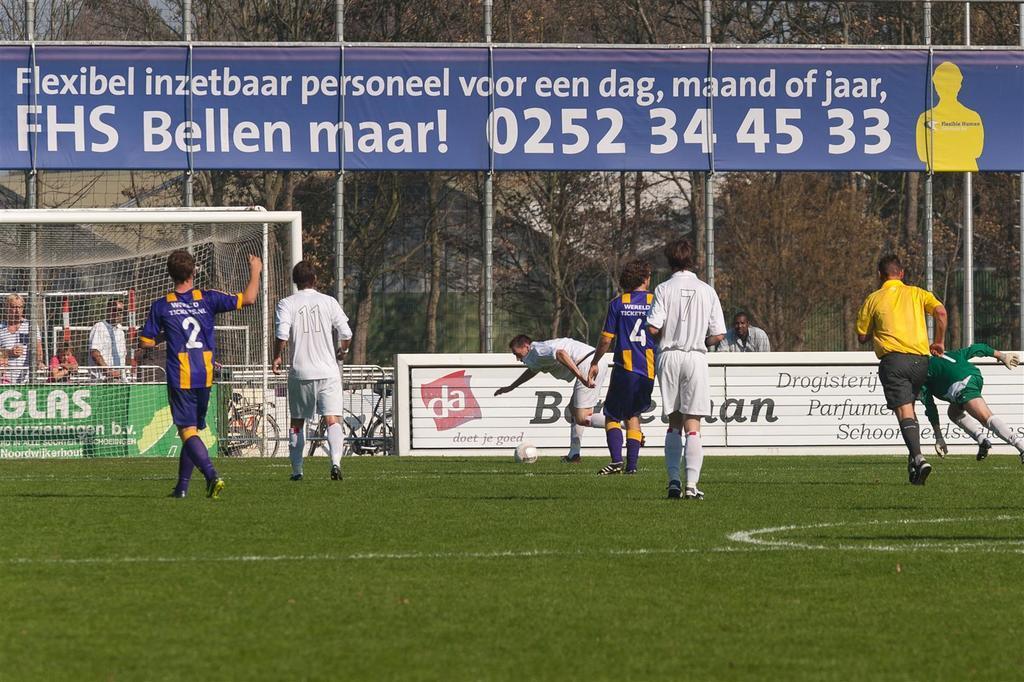Could you give a brief overview of what you see in this image? This picture is clicked outside. In the center we can see the group of persons wearing t-shirts and running on the ground and we can see a ball on the ground, the ground is covered with the green grass and we can see the text on the banners and we can see a picture and the numbers and text on a blue color banner and we can see the metal rods, mesh and some other objects. In the background we can see the trees and a person and some other objects. On the left we can see the group of persons. 